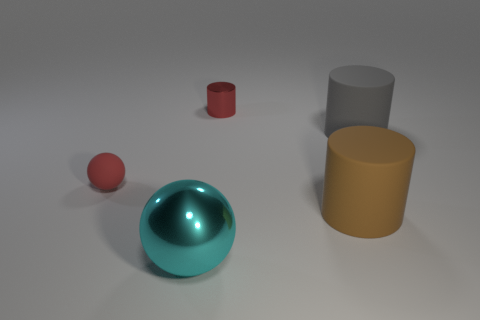Add 4 gray things. How many objects exist? 9 Subtract all big matte cylinders. How many cylinders are left? 1 Subtract 2 balls. How many balls are left? 0 Subtract all large cyan metallic spheres. Subtract all large cyan objects. How many objects are left? 3 Add 4 brown rubber objects. How many brown rubber objects are left? 5 Add 3 small red matte things. How many small red matte things exist? 4 Subtract all cyan spheres. How many spheres are left? 1 Subtract 0 green cylinders. How many objects are left? 5 Subtract all balls. How many objects are left? 3 Subtract all purple spheres. Subtract all red cylinders. How many spheres are left? 2 